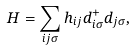<formula> <loc_0><loc_0><loc_500><loc_500>H = \sum _ { i j \sigma } h _ { i j } d ^ { + } _ { i \sigma } d _ { j \sigma } ,</formula> 